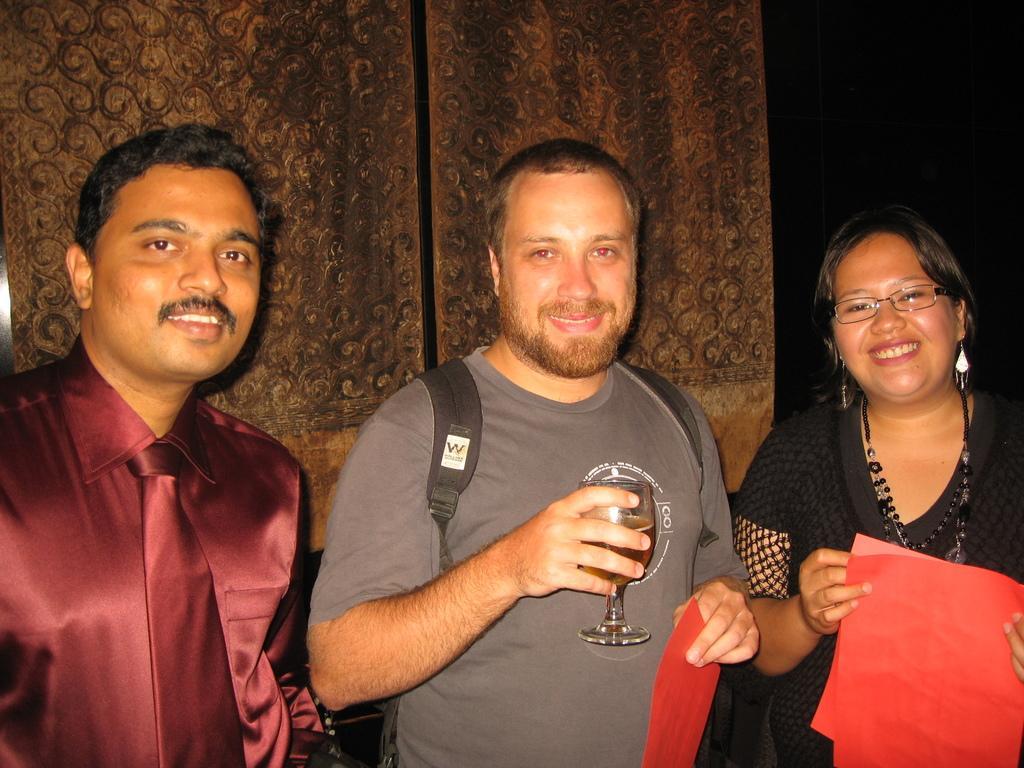Please provide a concise description of this image. In this picture we can see three persons smiling and the middle person holding glass in his hand and some paper on other hand and on right side woman also holding paper, left side person wore tie and in the background we can see wall. 